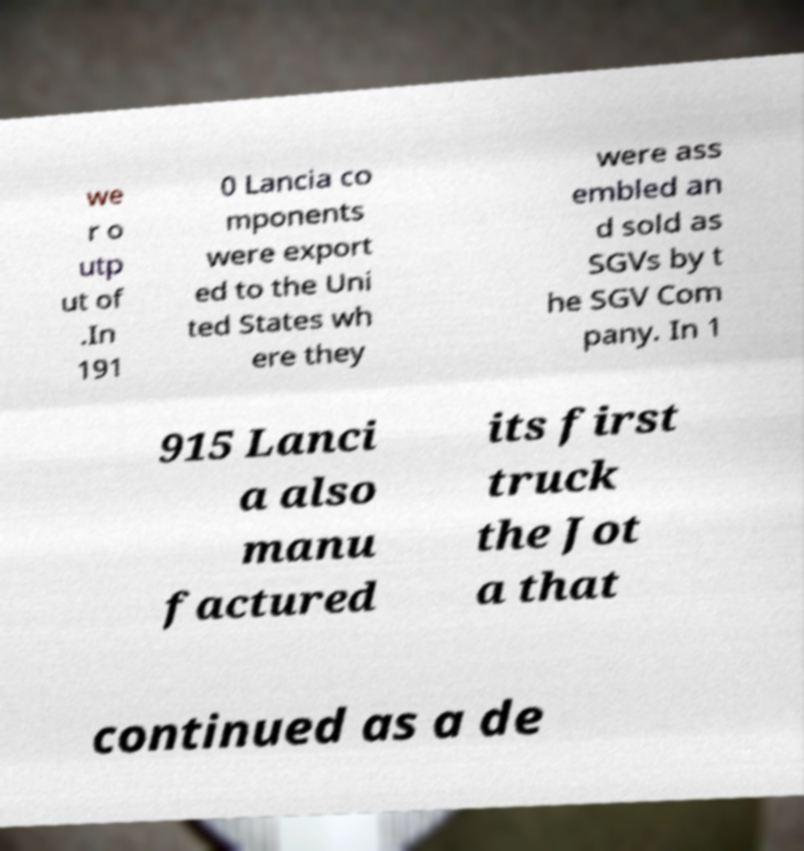I need the written content from this picture converted into text. Can you do that? we r o utp ut of .In 191 0 Lancia co mponents were export ed to the Uni ted States wh ere they were ass embled an d sold as SGVs by t he SGV Com pany. In 1 915 Lanci a also manu factured its first truck the Jot a that continued as a de 